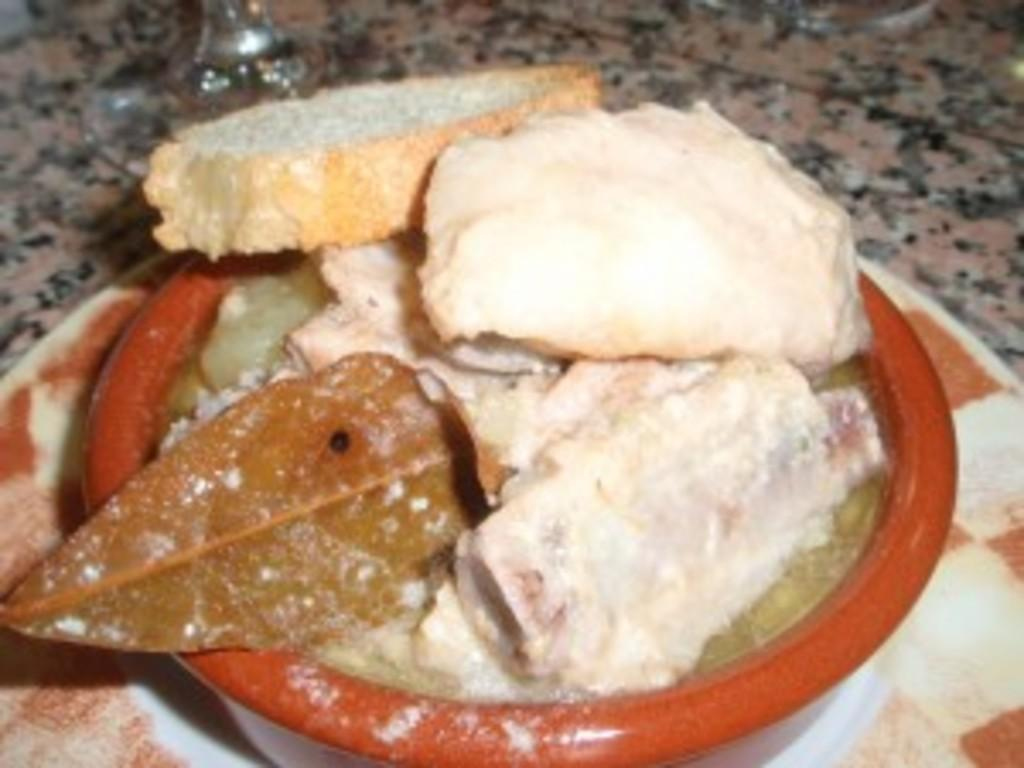What is present on the platform in the image? There is a plate and a bowl in the image. What is the purpose of the plate and bowl in the image? They are likely used for holding food, as there is food on the platform in the image. What type of sheet is draped over the stone in the image? There is no sheet or stone present in the image; it only features a plate, a bowl, and food on a platform. 